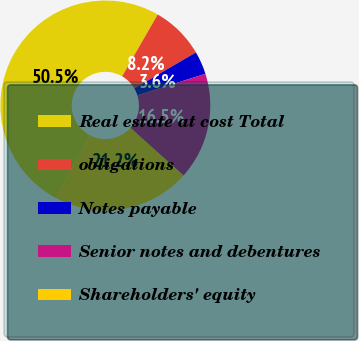Convert chart to OTSL. <chart><loc_0><loc_0><loc_500><loc_500><pie_chart><fcel>Real estate at cost Total<fcel>obligations<fcel>Notes payable<fcel>Senior notes and debentures<fcel>Shareholders' equity<nl><fcel>50.48%<fcel>8.25%<fcel>3.56%<fcel>16.51%<fcel>21.2%<nl></chart> 